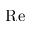Convert formula to latex. <formula><loc_0><loc_0><loc_500><loc_500>R e</formula> 